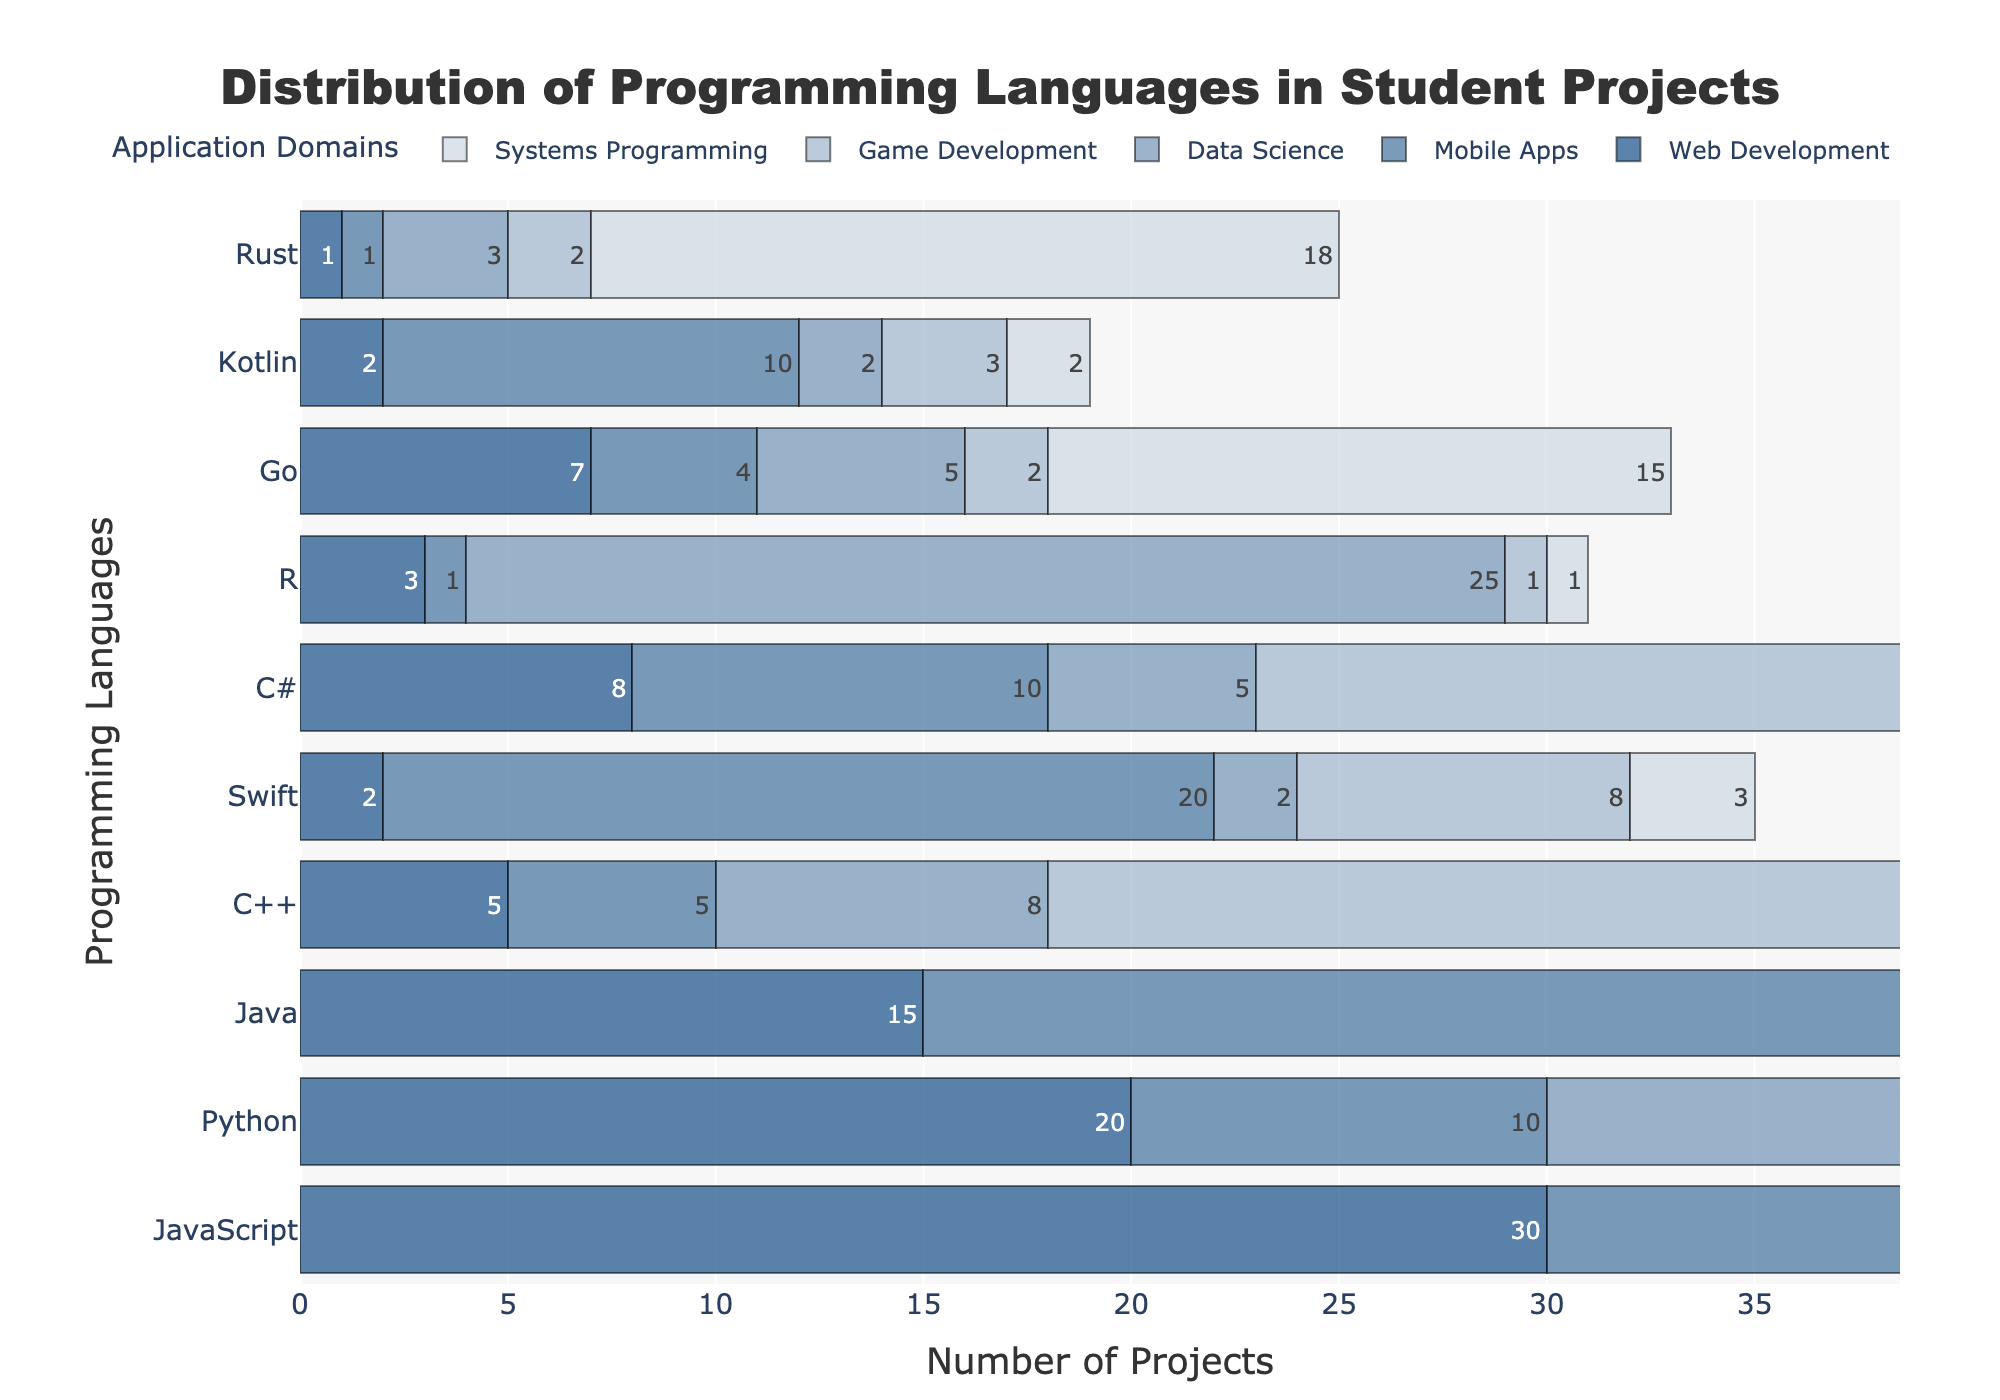What's the title of the figure? The title of the figure is prominently located at the top and reads "Distribution of Programming Languages in Student Projects".
Answer: Distribution of Programming Languages in Student Projects What is the most frequently used programming language for Web Development? From the figure, the length of the bar representing JavaScript is the longest in the Web Development category, indicating it is the most frequently used.
Answer: JavaScript Which programming language is most used in Data Science? By examining the Data Science section and comparing the lengths of the bars, Python has the longest bar, making it the most used language for Data Science.
Answer: Python Compare the usage of Java in Mobile Apps and Systems Programming. Looking at the figure, the bar for Java in Mobile Apps is longer than in Systems Programming. Specifically, Java's usage in Mobile Apps is 25 projects, whereas in Systems Programming, it is 12 projects.
Answer: Java is used more in Mobile Apps than in Systems Programming How many projects use Python for Game Development? The figure shows that the bar for Python in the Game Development category indicates 15 projects.
Answer: 15 What is the total number of projects for Web Development across all languages? By summing up the numbers for each language in Web Development from the figure: 30 (JavaScript) + 20 (Python) + 15 (Java) + 5 (C++) + 2 (Swift) + 8 (C#) + 3 (R) + 7 (Go) + 2 (Kotlin) + 1 (Rust) = 93 projects.
Answer: 93 Which application domain has the least usage of Rust? By comparing the lengths of the Rust bars across all application domains, Data Science and Mobile Apps both have the shortest bars with just 1 project each.
Answer: Data Science and Mobile Apps What is the difference in the number of projects using Swift for Mobile Apps versus for Data Science? From the figure, Swift is used in 20 Mobile Apps projects and 2 Data Science projects. The difference is 20 - 2 = 18 projects.
Answer: 18 How does the usage of Go compare between Web Development and Systems Programming? The bars indicate that Go is used in 7 Web Development projects and 15 Systems Programming projects. Therefore, Go is used more in Systems Programming.
Answer: Go is used more in Systems Programming compared to Web Development What is the average number of projects for C++ across all domains? Adding the number of projects for each domain for C++ from the figure: 5 (Web Development) + 5 (Mobile Apps) + 8 (Data Science) + 30 (Game Development) + 25 (Systems Programming) = 73. Dividing this by the number of domains (5), the average is 73/5 = 14.6.
Answer: 14.6 